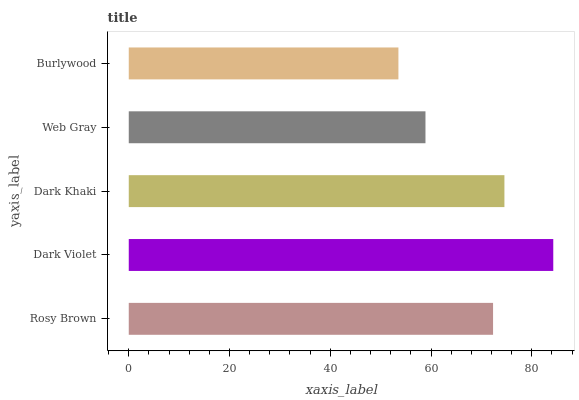Is Burlywood the minimum?
Answer yes or no. Yes. Is Dark Violet the maximum?
Answer yes or no. Yes. Is Dark Khaki the minimum?
Answer yes or no. No. Is Dark Khaki the maximum?
Answer yes or no. No. Is Dark Violet greater than Dark Khaki?
Answer yes or no. Yes. Is Dark Khaki less than Dark Violet?
Answer yes or no. Yes. Is Dark Khaki greater than Dark Violet?
Answer yes or no. No. Is Dark Violet less than Dark Khaki?
Answer yes or no. No. Is Rosy Brown the high median?
Answer yes or no. Yes. Is Rosy Brown the low median?
Answer yes or no. Yes. Is Web Gray the high median?
Answer yes or no. No. Is Dark Violet the low median?
Answer yes or no. No. 